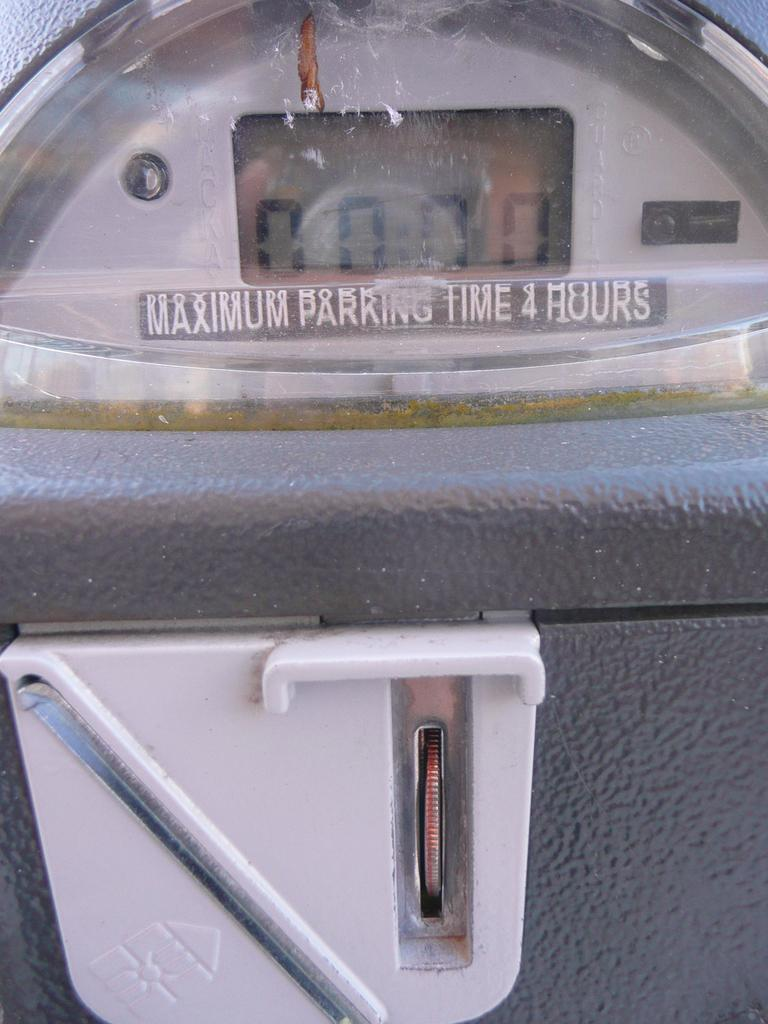<image>
Render a clear and concise summary of the photo. a parking meter with the warning of maximum parking time is four hours 